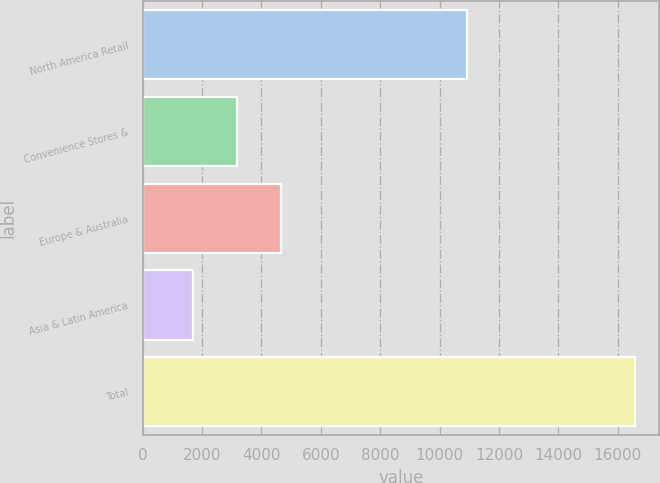<chart> <loc_0><loc_0><loc_500><loc_500><bar_chart><fcel>North America Retail<fcel>Convenience Stores &<fcel>Europe & Australia<fcel>Asia & Latin America<fcel>Total<nl><fcel>10936.6<fcel>3190.54<fcel>4676.38<fcel>1704.7<fcel>16563.1<nl></chart> 